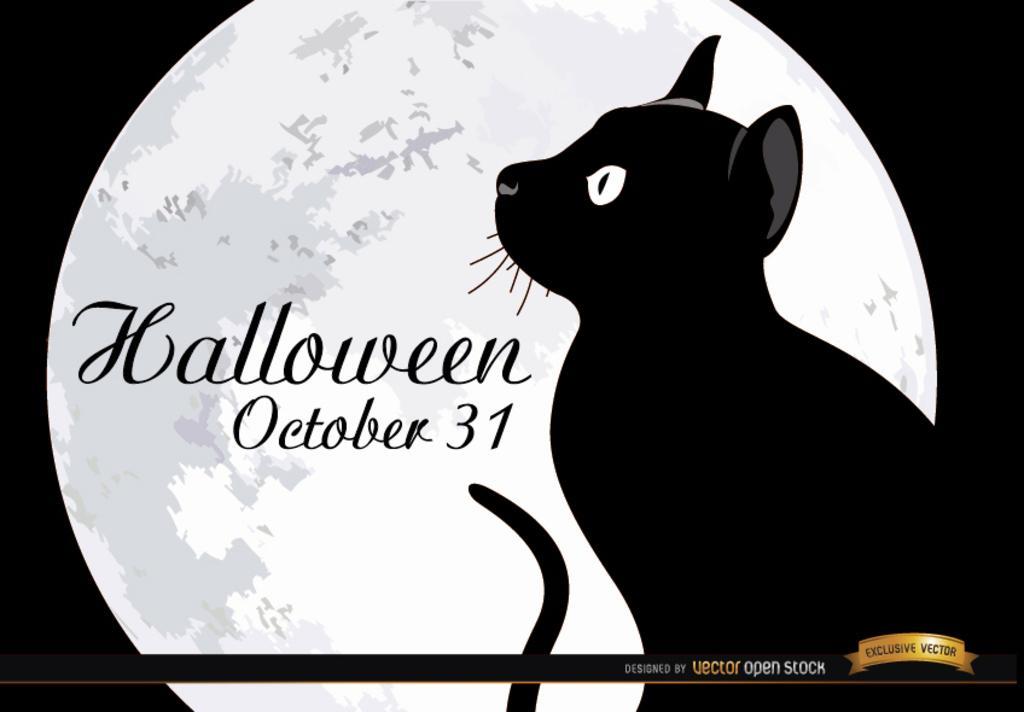Describe this image in one or two sentences. In this image we can see text and cat. Behind the cat moon is there. Right bottom of the image watermark is present. 